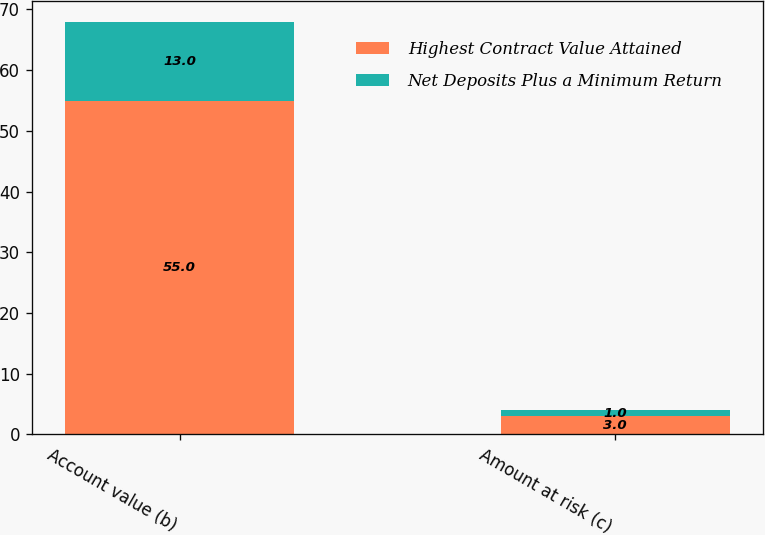Convert chart to OTSL. <chart><loc_0><loc_0><loc_500><loc_500><stacked_bar_chart><ecel><fcel>Account value (b)<fcel>Amount at risk (c)<nl><fcel>Highest Contract Value Attained<fcel>55<fcel>3<nl><fcel>Net Deposits Plus a Minimum Return<fcel>13<fcel>1<nl></chart> 